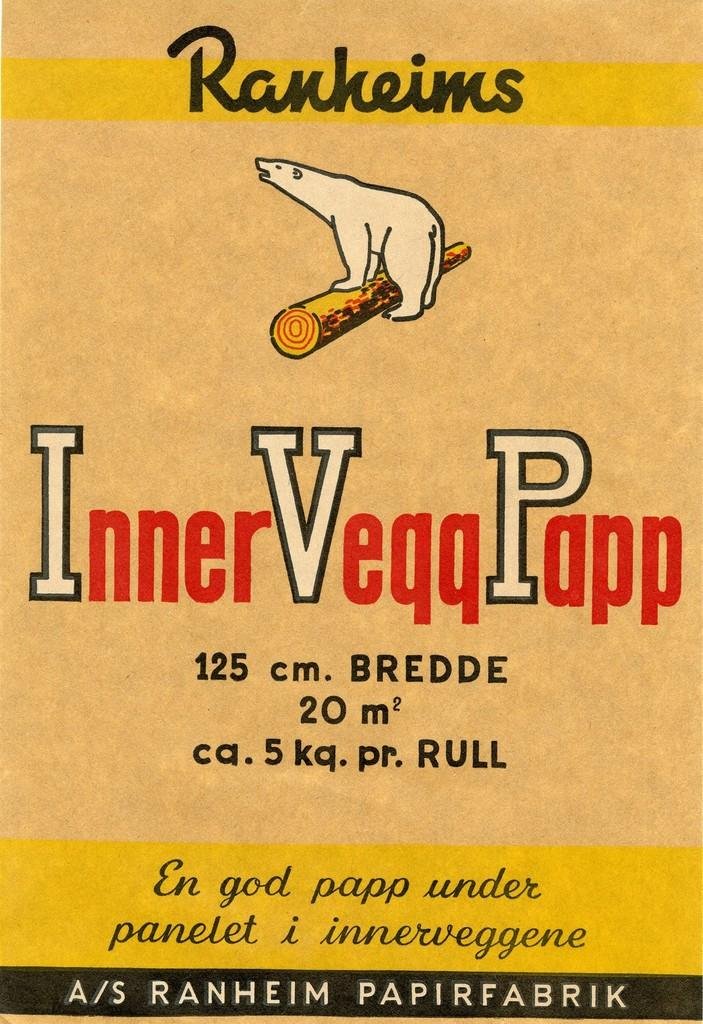<image>
Offer a succinct explanation of the picture presented. An advertisement for Inner Veqq Papp features a polar bear on a log. 